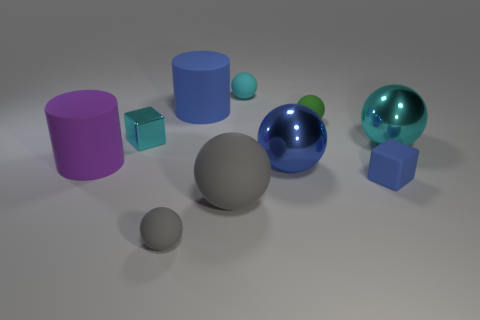Subtract all blue spheres. How many spheres are left? 5 Subtract all green balls. How many balls are left? 5 Subtract all blocks. How many objects are left? 8 Subtract 1 blocks. How many blocks are left? 1 Subtract all yellow spheres. How many blue cubes are left? 1 Subtract all cyan cubes. Subtract all cyan balls. How many objects are left? 7 Add 7 big rubber spheres. How many big rubber spheres are left? 8 Add 7 blue metal blocks. How many blue metal blocks exist? 7 Subtract 0 red blocks. How many objects are left? 10 Subtract all brown cubes. Subtract all purple balls. How many cubes are left? 2 